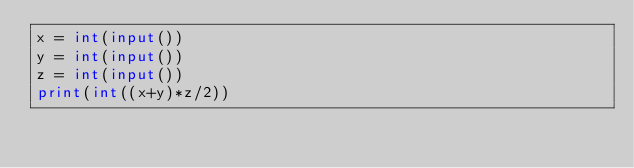Convert code to text. <code><loc_0><loc_0><loc_500><loc_500><_Python_>x = int(input())
y = int(input())
z = int(input())
print(int((x+y)*z/2))
</code> 